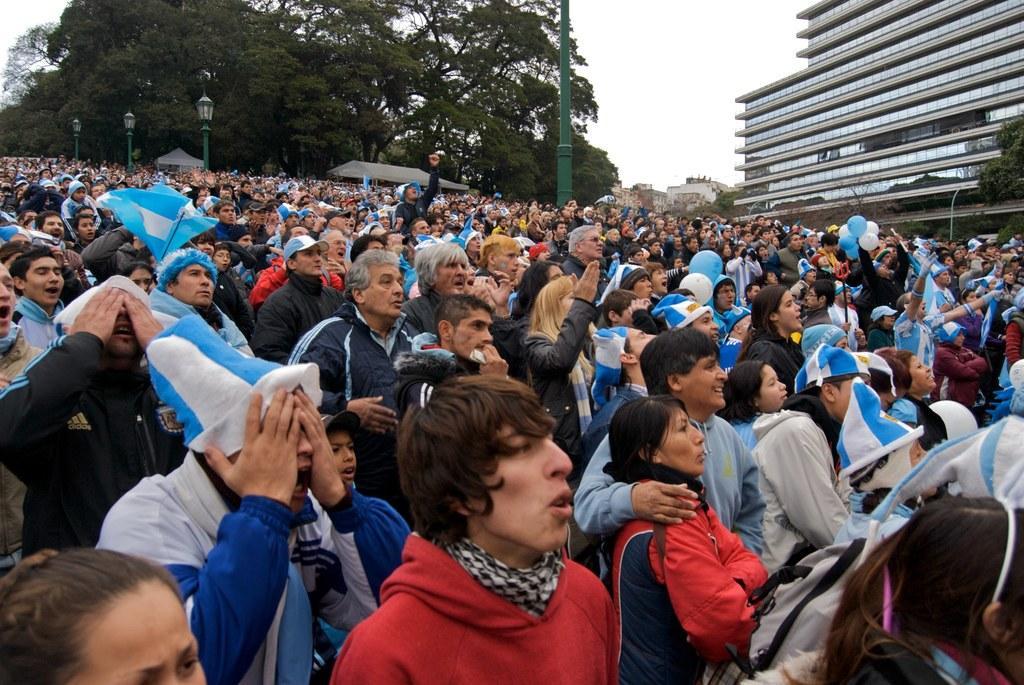Describe this image in one or two sentences. In this image I can see a crowd on the road. In the background I can see buildings, trees, light poles and the sky. This image is taken may be during a day. 